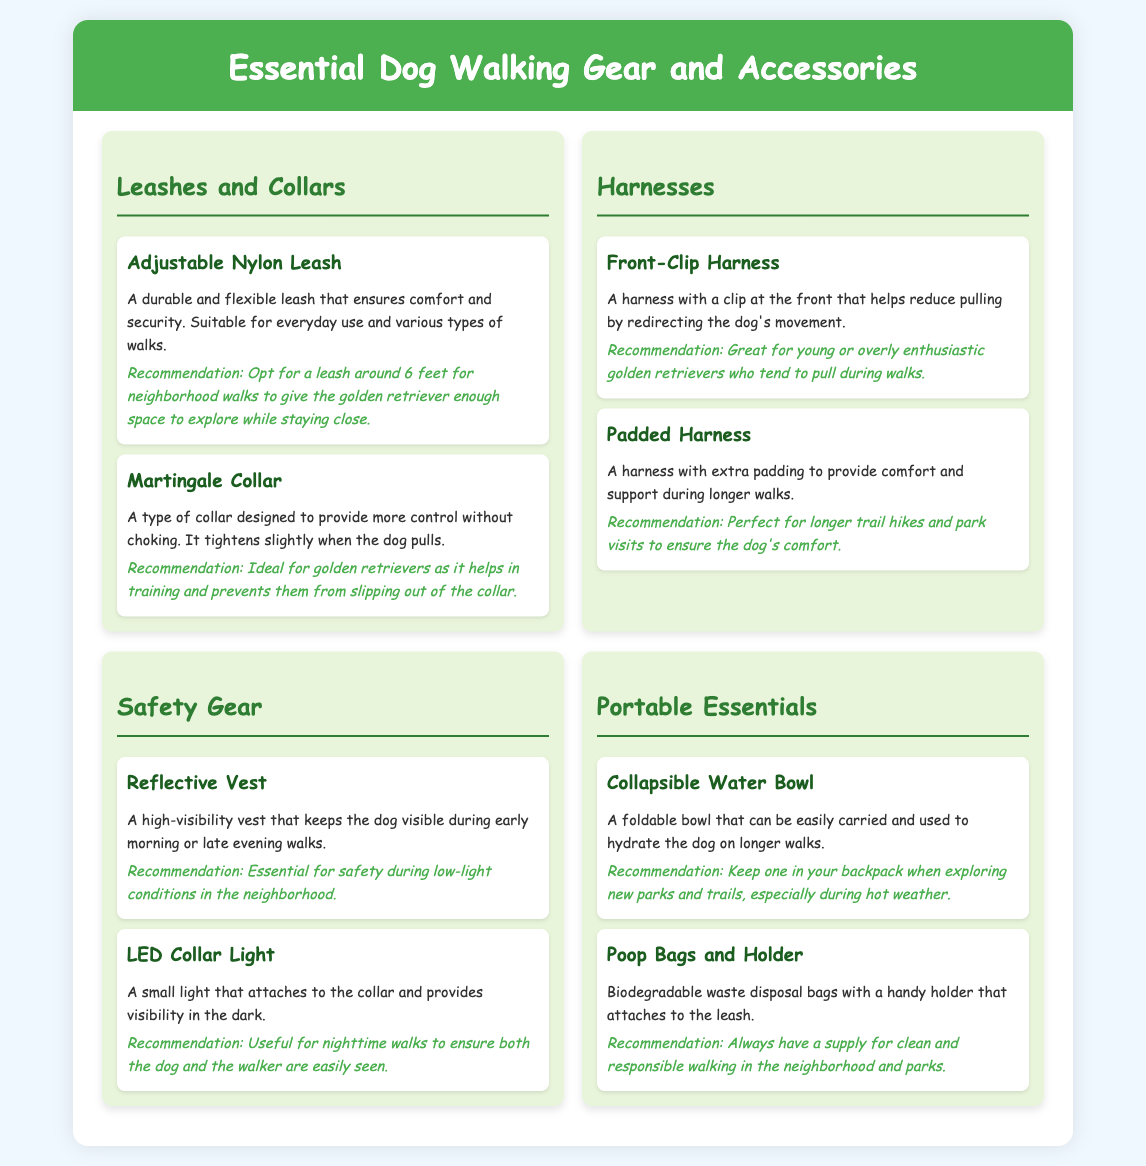What is an example of a leash? The document provides an example of an adjustable nylon leash in the leashes and collars section.
Answer: Adjustable Nylon Leash What is recommended for nighttime walks? The LED collar light is mentioned as useful for nighttime walks to ensure visibility.
Answer: LED Collar Light What type of harness helps reduce pulling? The front-clip harness is described as helping to reduce pulling by redirecting the dog's movement.
Answer: Front-Clip Harness Which item is essential for safety during low-light conditions? The reflective vest is specifically noted as essential for safety during early morning or late evening walks.
Answer: Reflective Vest What should you carry for hydration on longer walks? The document suggests using a collapsible water bowl to hydrate the dog on longer walks.
Answer: Collapsible Water Bowl What does the martingale collar do? The martingale collar is designed to provide control without choking and prevents slipping out of the collar.
Answer: Provides control without choking What type of poop bags are recommended? Biodegradable waste disposal bags are highlighted as the recommended type for responsible walking.
Answer: Biodegradable waste disposal bags What is the ideal length for a neighborhood leash? The recommendation suggests a leash around 6 feet for neighborhood walks.
Answer: 6 feet Which harness is perfect for longer trail hikes? The padded harness is described as perfect for longer trail hikes to ensure comfort.
Answer: Padded Harness 